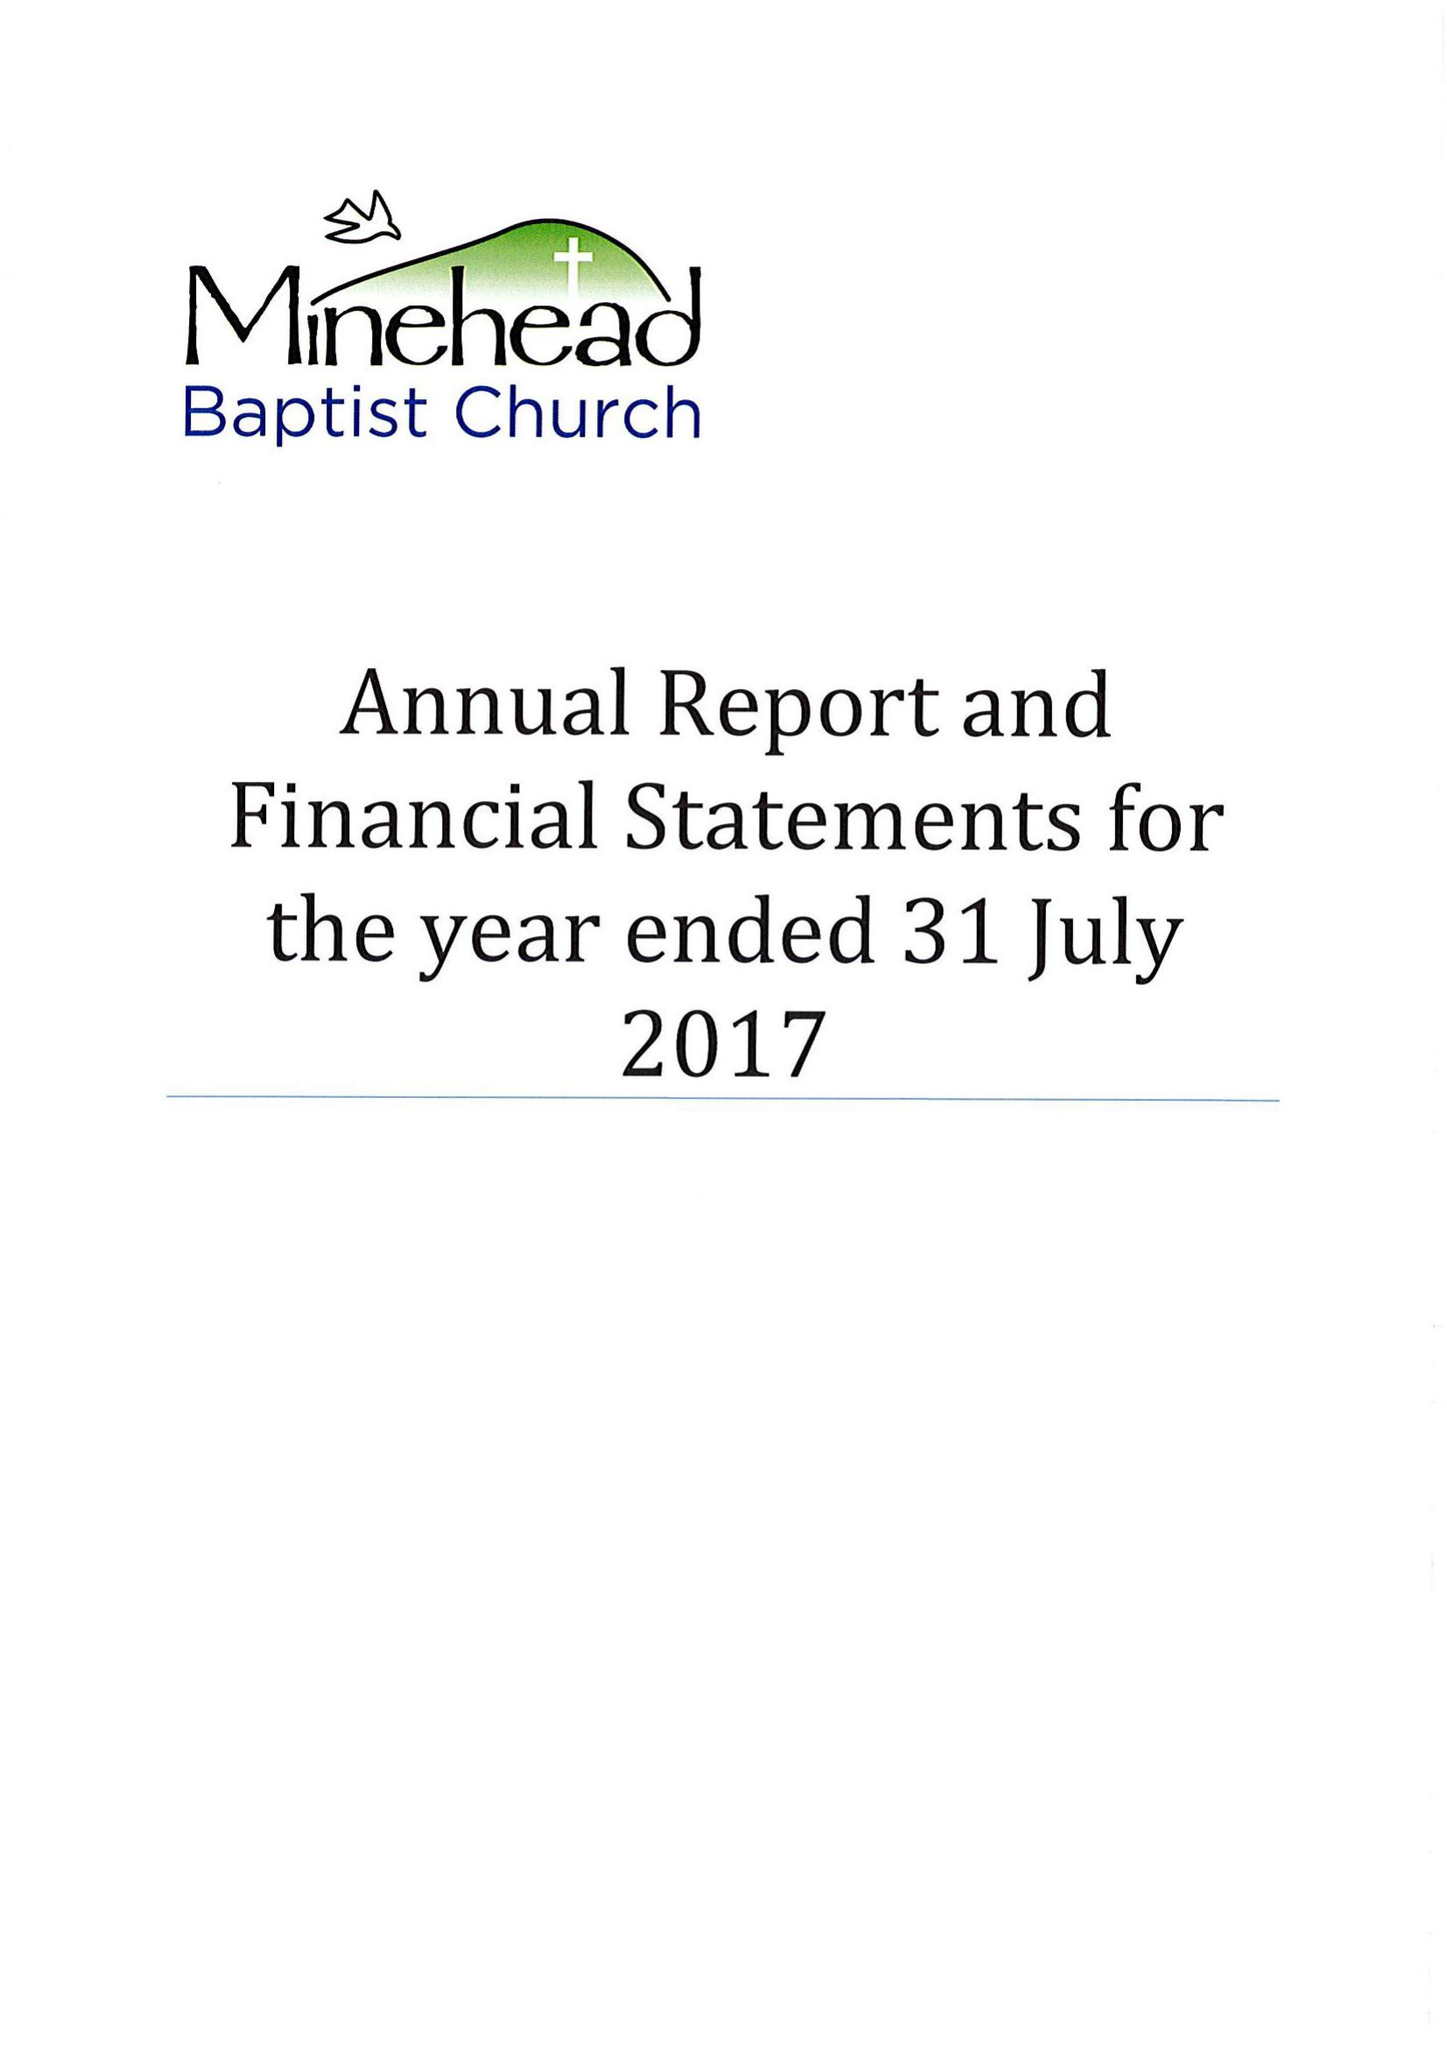What is the value for the address__post_town?
Answer the question using a single word or phrase. MINEHEAD 